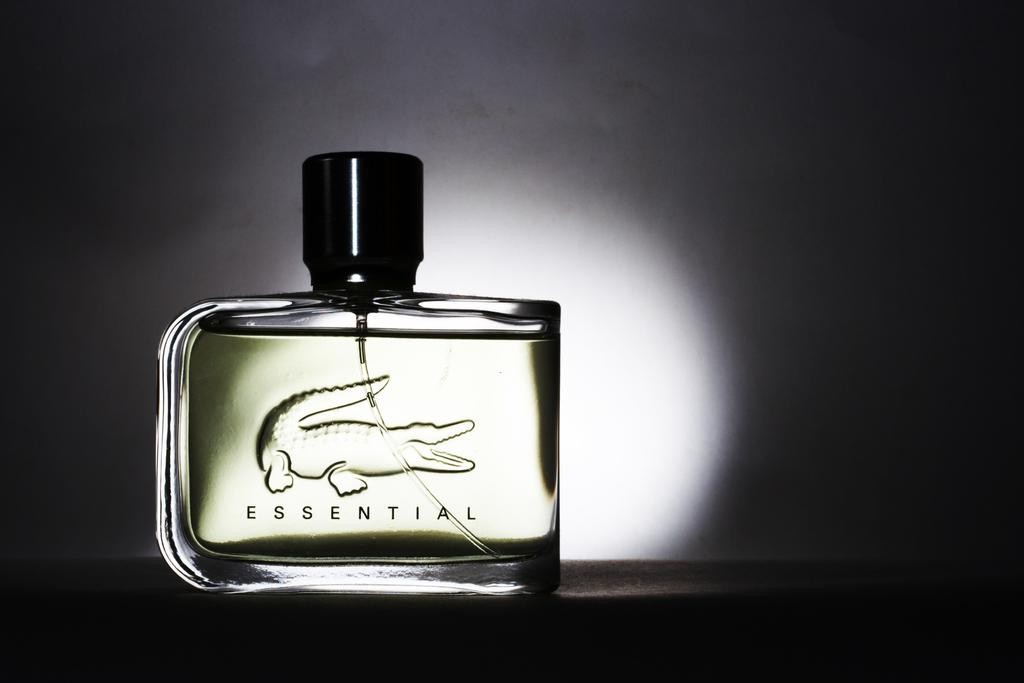<image>
Provide a brief description of the given image. A bottle of Essential cologne with a black top. 